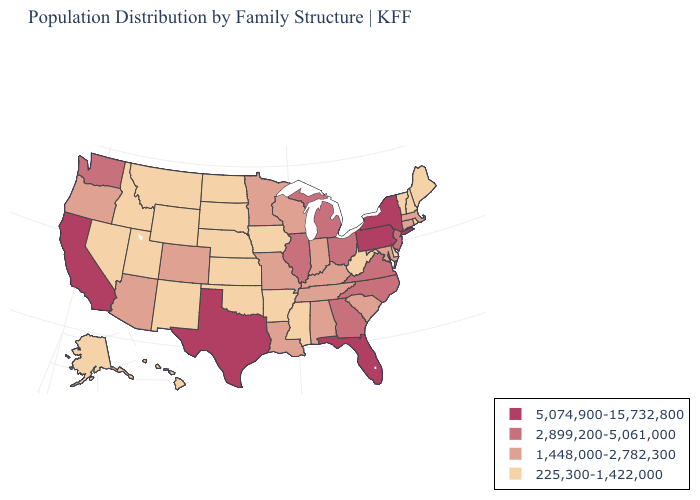Does the first symbol in the legend represent the smallest category?
Answer briefly. No. What is the value of Delaware?
Keep it brief. 225,300-1,422,000. Which states hav the highest value in the MidWest?
Give a very brief answer. Illinois, Michigan, Ohio. What is the lowest value in the South?
Quick response, please. 225,300-1,422,000. What is the value of Tennessee?
Keep it brief. 1,448,000-2,782,300. Does New Hampshire have the lowest value in the Northeast?
Short answer required. Yes. Does New Jersey have a higher value than Pennsylvania?
Keep it brief. No. Which states have the lowest value in the MidWest?
Be succinct. Iowa, Kansas, Nebraska, North Dakota, South Dakota. Which states have the highest value in the USA?
Concise answer only. California, Florida, New York, Pennsylvania, Texas. What is the value of Ohio?
Keep it brief. 2,899,200-5,061,000. What is the value of North Dakota?
Keep it brief. 225,300-1,422,000. What is the value of Rhode Island?
Quick response, please. 225,300-1,422,000. Name the states that have a value in the range 2,899,200-5,061,000?
Concise answer only. Georgia, Illinois, Michigan, New Jersey, North Carolina, Ohio, Virginia, Washington. Which states hav the highest value in the Northeast?
Quick response, please. New York, Pennsylvania. Among the states that border Massachusetts , does New York have the highest value?
Concise answer only. Yes. 